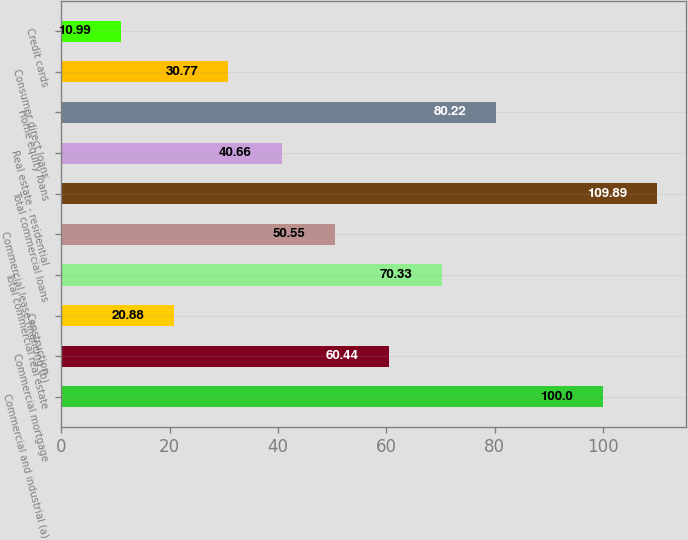Convert chart. <chart><loc_0><loc_0><loc_500><loc_500><bar_chart><fcel>Commercial and industrial (a)<fcel>Commercial mortgage<fcel>Construction<fcel>Total commercial real estate<fcel>Commercial lease financing (b)<fcel>Total commercial loans<fcel>Real estate - residential<fcel>Home equity loans<fcel>Consumer direct loans<fcel>Credit cards<nl><fcel>100<fcel>60.44<fcel>20.88<fcel>70.33<fcel>50.55<fcel>109.89<fcel>40.66<fcel>80.22<fcel>30.77<fcel>10.99<nl></chart> 